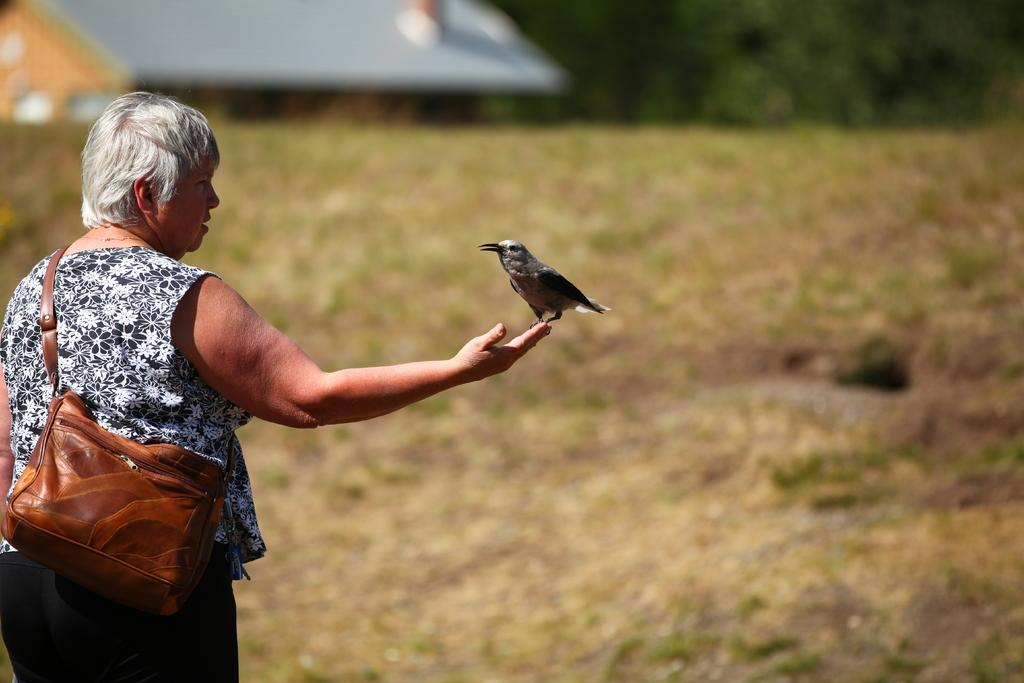Who is present in the image? There is a woman in the image. What is the woman doing in the image? The woman is standing on the ground. What is on the woman's hand in the image? There is a bird on the woman's hand. What is the woman carrying in the image? The woman is carrying a bag. What type of amusement park ride is visible in the image? There is no amusement park ride present in the image. How many toes can be seen on the woman's foot in the image? The image does not show the woman's foot, so the number of toes cannot be determined. 